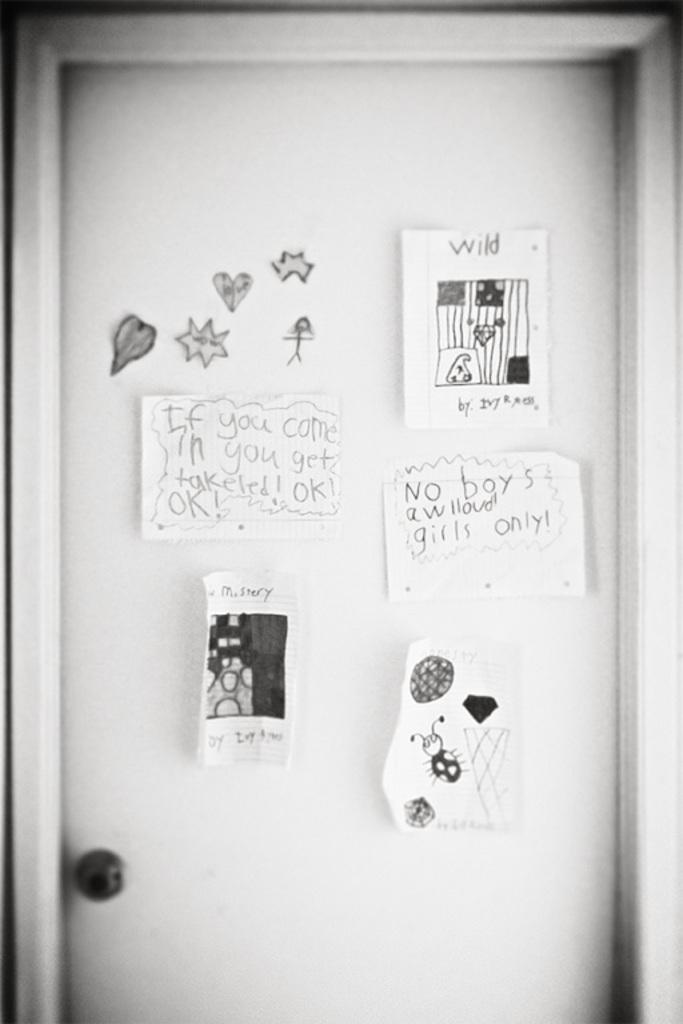What type of door is shown in the image? There is a wooden door in the image. What is attached to the wooden door? There are paper posters on the door. How many frogs can be seen on the wooden door in the image? There are no frogs present on the wooden door in the image. 